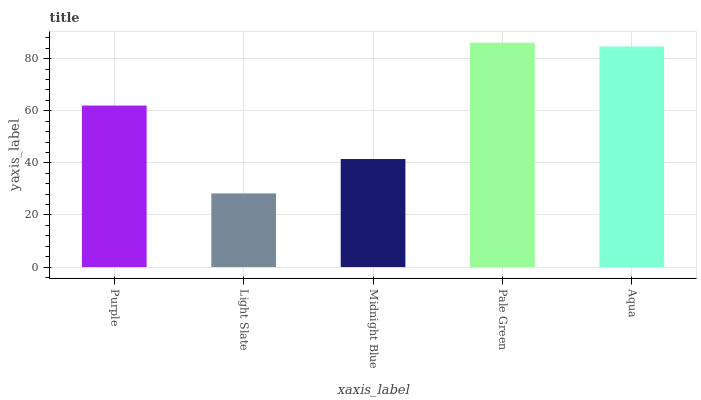Is Midnight Blue the minimum?
Answer yes or no. No. Is Midnight Blue the maximum?
Answer yes or no. No. Is Midnight Blue greater than Light Slate?
Answer yes or no. Yes. Is Light Slate less than Midnight Blue?
Answer yes or no. Yes. Is Light Slate greater than Midnight Blue?
Answer yes or no. No. Is Midnight Blue less than Light Slate?
Answer yes or no. No. Is Purple the high median?
Answer yes or no. Yes. Is Purple the low median?
Answer yes or no. Yes. Is Pale Green the high median?
Answer yes or no. No. Is Aqua the low median?
Answer yes or no. No. 